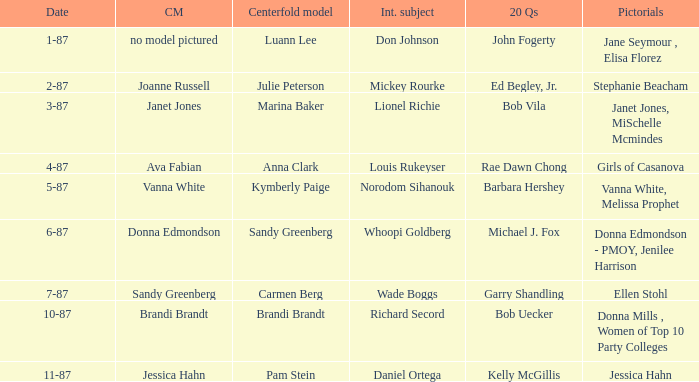When was the Kymberly Paige the Centerfold? 5-87. Parse the table in full. {'header': ['Date', 'CM', 'Centerfold model', 'Int. subject', '20 Qs', 'Pictorials'], 'rows': [['1-87', 'no model pictured', 'Luann Lee', 'Don Johnson', 'John Fogerty', 'Jane Seymour , Elisa Florez'], ['2-87', 'Joanne Russell', 'Julie Peterson', 'Mickey Rourke', 'Ed Begley, Jr.', 'Stephanie Beacham'], ['3-87', 'Janet Jones', 'Marina Baker', 'Lionel Richie', 'Bob Vila', 'Janet Jones, MiSchelle Mcmindes'], ['4-87', 'Ava Fabian', 'Anna Clark', 'Louis Rukeyser', 'Rae Dawn Chong', 'Girls of Casanova'], ['5-87', 'Vanna White', 'Kymberly Paige', 'Norodom Sihanouk', 'Barbara Hershey', 'Vanna White, Melissa Prophet'], ['6-87', 'Donna Edmondson', 'Sandy Greenberg', 'Whoopi Goldberg', 'Michael J. Fox', 'Donna Edmondson - PMOY, Jenilee Harrison'], ['7-87', 'Sandy Greenberg', 'Carmen Berg', 'Wade Boggs', 'Garry Shandling', 'Ellen Stohl'], ['10-87', 'Brandi Brandt', 'Brandi Brandt', 'Richard Secord', 'Bob Uecker', 'Donna Mills , Women of Top 10 Party Colleges'], ['11-87', 'Jessica Hahn', 'Pam Stein', 'Daniel Ortega', 'Kelly McGillis', 'Jessica Hahn']]} 